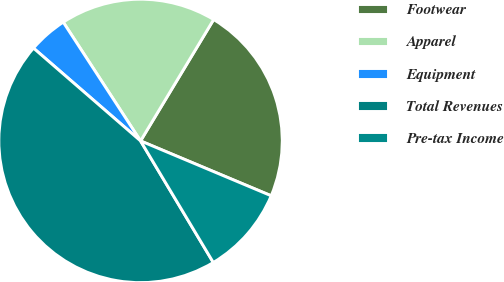Convert chart to OTSL. <chart><loc_0><loc_0><loc_500><loc_500><pie_chart><fcel>Footwear<fcel>Apparel<fcel>Equipment<fcel>Total Revenues<fcel>Pre-tax Income<nl><fcel>22.7%<fcel>17.81%<fcel>4.45%<fcel>44.95%<fcel>10.09%<nl></chart> 